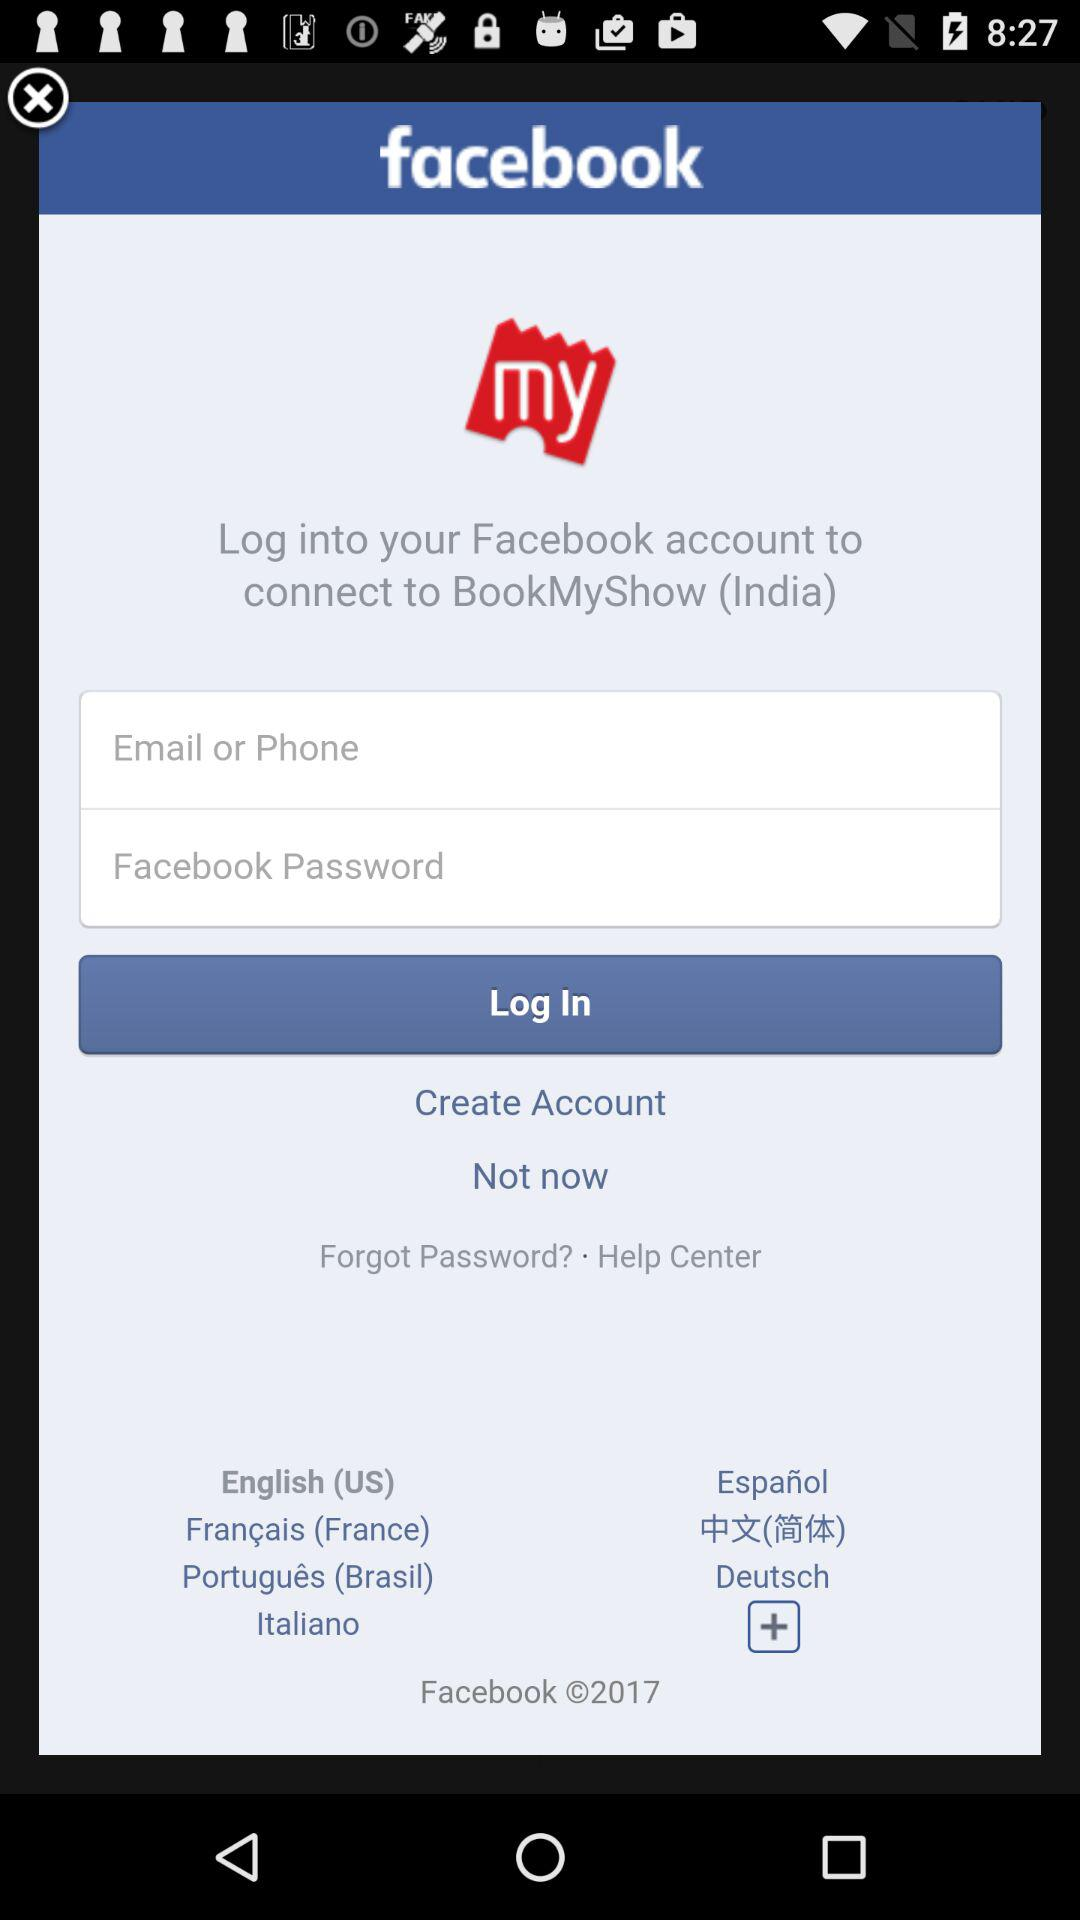How many countries are available to choose from in the language selection?
Answer the question using a single word or phrase. 7 